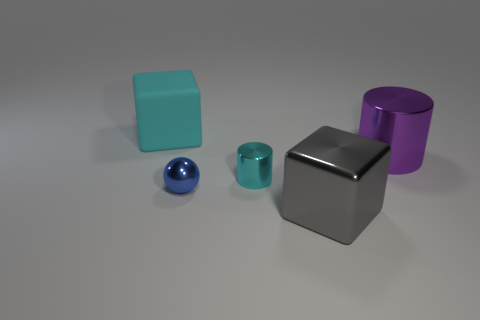Add 4 gray blocks. How many objects exist? 9 Subtract all cubes. How many objects are left? 3 Subtract all cyan cubes. How many cubes are left? 1 Add 2 big rubber cubes. How many big rubber cubes are left? 3 Add 4 tiny cyan metal objects. How many tiny cyan metal objects exist? 5 Subtract 1 blue spheres. How many objects are left? 4 Subtract 1 blocks. How many blocks are left? 1 Subtract all red balls. Subtract all red cylinders. How many balls are left? 1 Subtract all brown balls. How many yellow cylinders are left? 0 Subtract all cyan rubber blocks. Subtract all blue things. How many objects are left? 3 